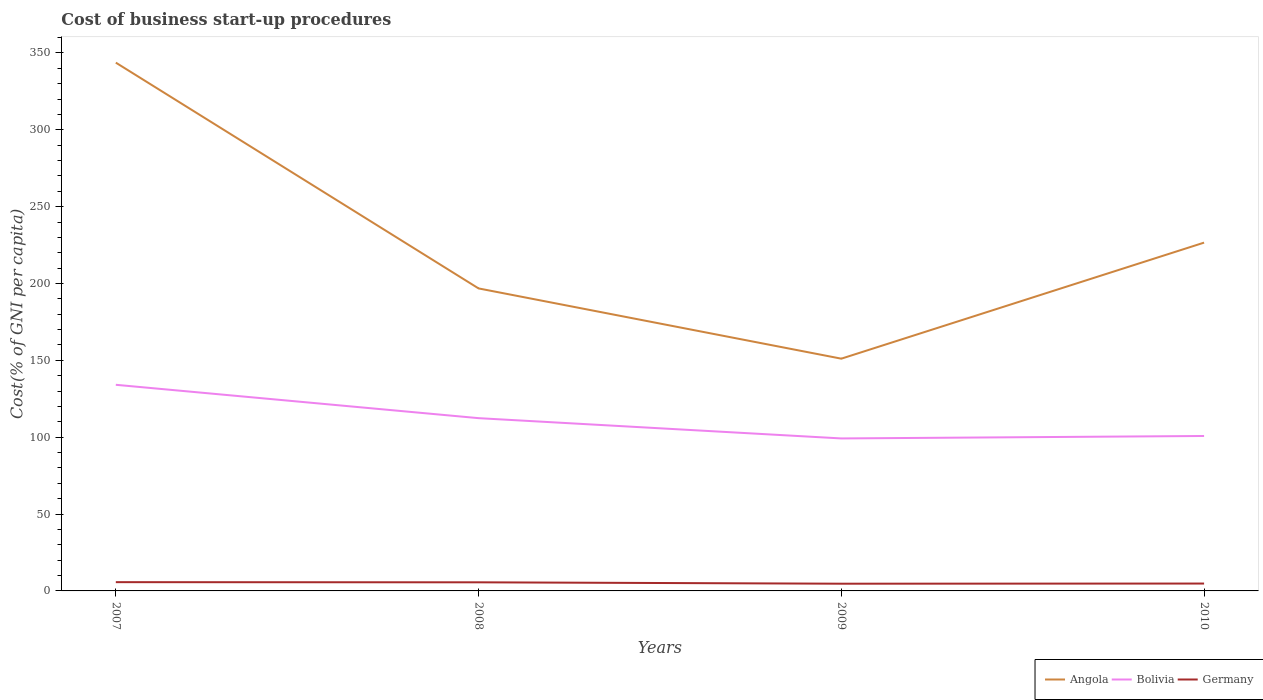Across all years, what is the maximum cost of business start-up procedures in Bolivia?
Your response must be concise. 99.2. What is the total cost of business start-up procedures in Germany in the graph?
Provide a short and direct response. 0.9. What is the difference between the highest and the second highest cost of business start-up procedures in Angola?
Ensure brevity in your answer.  192.6. What is the difference between the highest and the lowest cost of business start-up procedures in Germany?
Your response must be concise. 2. Is the cost of business start-up procedures in Bolivia strictly greater than the cost of business start-up procedures in Germany over the years?
Keep it short and to the point. No. How many lines are there?
Provide a short and direct response. 3. How many years are there in the graph?
Offer a terse response. 4. What is the difference between two consecutive major ticks on the Y-axis?
Provide a short and direct response. 50. What is the title of the graph?
Your response must be concise. Cost of business start-up procedures. Does "OECD members" appear as one of the legend labels in the graph?
Give a very brief answer. No. What is the label or title of the X-axis?
Your answer should be very brief. Years. What is the label or title of the Y-axis?
Make the answer very short. Cost(% of GNI per capita). What is the Cost(% of GNI per capita) of Angola in 2007?
Make the answer very short. 343.7. What is the Cost(% of GNI per capita) in Bolivia in 2007?
Offer a very short reply. 134.1. What is the Cost(% of GNI per capita) of Angola in 2008?
Give a very brief answer. 196.8. What is the Cost(% of GNI per capita) of Bolivia in 2008?
Make the answer very short. 112.4. What is the Cost(% of GNI per capita) in Angola in 2009?
Give a very brief answer. 151.1. What is the Cost(% of GNI per capita) of Bolivia in 2009?
Provide a succinct answer. 99.2. What is the Cost(% of GNI per capita) in Angola in 2010?
Your response must be concise. 226.6. What is the Cost(% of GNI per capita) of Bolivia in 2010?
Make the answer very short. 100.8. What is the Cost(% of GNI per capita) of Germany in 2010?
Keep it short and to the point. 4.8. Across all years, what is the maximum Cost(% of GNI per capita) of Angola?
Your response must be concise. 343.7. Across all years, what is the maximum Cost(% of GNI per capita) of Bolivia?
Make the answer very short. 134.1. Across all years, what is the maximum Cost(% of GNI per capita) in Germany?
Provide a short and direct response. 5.7. Across all years, what is the minimum Cost(% of GNI per capita) in Angola?
Provide a short and direct response. 151.1. Across all years, what is the minimum Cost(% of GNI per capita) in Bolivia?
Offer a very short reply. 99.2. Across all years, what is the minimum Cost(% of GNI per capita) of Germany?
Offer a very short reply. 4.7. What is the total Cost(% of GNI per capita) of Angola in the graph?
Your response must be concise. 918.2. What is the total Cost(% of GNI per capita) of Bolivia in the graph?
Keep it short and to the point. 446.5. What is the total Cost(% of GNI per capita) in Germany in the graph?
Provide a short and direct response. 20.8. What is the difference between the Cost(% of GNI per capita) of Angola in 2007 and that in 2008?
Keep it short and to the point. 146.9. What is the difference between the Cost(% of GNI per capita) in Bolivia in 2007 and that in 2008?
Your answer should be compact. 21.7. What is the difference between the Cost(% of GNI per capita) in Germany in 2007 and that in 2008?
Offer a terse response. 0.1. What is the difference between the Cost(% of GNI per capita) of Angola in 2007 and that in 2009?
Your answer should be compact. 192.6. What is the difference between the Cost(% of GNI per capita) in Bolivia in 2007 and that in 2009?
Offer a very short reply. 34.9. What is the difference between the Cost(% of GNI per capita) in Germany in 2007 and that in 2009?
Offer a terse response. 1. What is the difference between the Cost(% of GNI per capita) in Angola in 2007 and that in 2010?
Provide a short and direct response. 117.1. What is the difference between the Cost(% of GNI per capita) of Bolivia in 2007 and that in 2010?
Ensure brevity in your answer.  33.3. What is the difference between the Cost(% of GNI per capita) in Angola in 2008 and that in 2009?
Offer a very short reply. 45.7. What is the difference between the Cost(% of GNI per capita) of Bolivia in 2008 and that in 2009?
Ensure brevity in your answer.  13.2. What is the difference between the Cost(% of GNI per capita) of Germany in 2008 and that in 2009?
Make the answer very short. 0.9. What is the difference between the Cost(% of GNI per capita) of Angola in 2008 and that in 2010?
Provide a short and direct response. -29.8. What is the difference between the Cost(% of GNI per capita) in Angola in 2009 and that in 2010?
Ensure brevity in your answer.  -75.5. What is the difference between the Cost(% of GNI per capita) in Bolivia in 2009 and that in 2010?
Offer a very short reply. -1.6. What is the difference between the Cost(% of GNI per capita) of Angola in 2007 and the Cost(% of GNI per capita) of Bolivia in 2008?
Your answer should be very brief. 231.3. What is the difference between the Cost(% of GNI per capita) of Angola in 2007 and the Cost(% of GNI per capita) of Germany in 2008?
Give a very brief answer. 338.1. What is the difference between the Cost(% of GNI per capita) of Bolivia in 2007 and the Cost(% of GNI per capita) of Germany in 2008?
Offer a terse response. 128.5. What is the difference between the Cost(% of GNI per capita) of Angola in 2007 and the Cost(% of GNI per capita) of Bolivia in 2009?
Offer a very short reply. 244.5. What is the difference between the Cost(% of GNI per capita) in Angola in 2007 and the Cost(% of GNI per capita) in Germany in 2009?
Your response must be concise. 339. What is the difference between the Cost(% of GNI per capita) of Bolivia in 2007 and the Cost(% of GNI per capita) of Germany in 2009?
Make the answer very short. 129.4. What is the difference between the Cost(% of GNI per capita) of Angola in 2007 and the Cost(% of GNI per capita) of Bolivia in 2010?
Make the answer very short. 242.9. What is the difference between the Cost(% of GNI per capita) of Angola in 2007 and the Cost(% of GNI per capita) of Germany in 2010?
Make the answer very short. 338.9. What is the difference between the Cost(% of GNI per capita) in Bolivia in 2007 and the Cost(% of GNI per capita) in Germany in 2010?
Keep it short and to the point. 129.3. What is the difference between the Cost(% of GNI per capita) of Angola in 2008 and the Cost(% of GNI per capita) of Bolivia in 2009?
Provide a succinct answer. 97.6. What is the difference between the Cost(% of GNI per capita) of Angola in 2008 and the Cost(% of GNI per capita) of Germany in 2009?
Ensure brevity in your answer.  192.1. What is the difference between the Cost(% of GNI per capita) of Bolivia in 2008 and the Cost(% of GNI per capita) of Germany in 2009?
Provide a short and direct response. 107.7. What is the difference between the Cost(% of GNI per capita) in Angola in 2008 and the Cost(% of GNI per capita) in Bolivia in 2010?
Keep it short and to the point. 96. What is the difference between the Cost(% of GNI per capita) of Angola in 2008 and the Cost(% of GNI per capita) of Germany in 2010?
Provide a short and direct response. 192. What is the difference between the Cost(% of GNI per capita) in Bolivia in 2008 and the Cost(% of GNI per capita) in Germany in 2010?
Give a very brief answer. 107.6. What is the difference between the Cost(% of GNI per capita) of Angola in 2009 and the Cost(% of GNI per capita) of Bolivia in 2010?
Give a very brief answer. 50.3. What is the difference between the Cost(% of GNI per capita) of Angola in 2009 and the Cost(% of GNI per capita) of Germany in 2010?
Offer a terse response. 146.3. What is the difference between the Cost(% of GNI per capita) of Bolivia in 2009 and the Cost(% of GNI per capita) of Germany in 2010?
Offer a very short reply. 94.4. What is the average Cost(% of GNI per capita) in Angola per year?
Ensure brevity in your answer.  229.55. What is the average Cost(% of GNI per capita) of Bolivia per year?
Make the answer very short. 111.62. What is the average Cost(% of GNI per capita) of Germany per year?
Your response must be concise. 5.2. In the year 2007, what is the difference between the Cost(% of GNI per capita) of Angola and Cost(% of GNI per capita) of Bolivia?
Offer a very short reply. 209.6. In the year 2007, what is the difference between the Cost(% of GNI per capita) in Angola and Cost(% of GNI per capita) in Germany?
Your response must be concise. 338. In the year 2007, what is the difference between the Cost(% of GNI per capita) of Bolivia and Cost(% of GNI per capita) of Germany?
Your response must be concise. 128.4. In the year 2008, what is the difference between the Cost(% of GNI per capita) of Angola and Cost(% of GNI per capita) of Bolivia?
Your answer should be very brief. 84.4. In the year 2008, what is the difference between the Cost(% of GNI per capita) in Angola and Cost(% of GNI per capita) in Germany?
Offer a very short reply. 191.2. In the year 2008, what is the difference between the Cost(% of GNI per capita) in Bolivia and Cost(% of GNI per capita) in Germany?
Your answer should be compact. 106.8. In the year 2009, what is the difference between the Cost(% of GNI per capita) in Angola and Cost(% of GNI per capita) in Bolivia?
Provide a short and direct response. 51.9. In the year 2009, what is the difference between the Cost(% of GNI per capita) in Angola and Cost(% of GNI per capita) in Germany?
Provide a succinct answer. 146.4. In the year 2009, what is the difference between the Cost(% of GNI per capita) in Bolivia and Cost(% of GNI per capita) in Germany?
Your response must be concise. 94.5. In the year 2010, what is the difference between the Cost(% of GNI per capita) in Angola and Cost(% of GNI per capita) in Bolivia?
Offer a very short reply. 125.8. In the year 2010, what is the difference between the Cost(% of GNI per capita) of Angola and Cost(% of GNI per capita) of Germany?
Ensure brevity in your answer.  221.8. In the year 2010, what is the difference between the Cost(% of GNI per capita) of Bolivia and Cost(% of GNI per capita) of Germany?
Provide a short and direct response. 96. What is the ratio of the Cost(% of GNI per capita) of Angola in 2007 to that in 2008?
Provide a succinct answer. 1.75. What is the ratio of the Cost(% of GNI per capita) in Bolivia in 2007 to that in 2008?
Provide a short and direct response. 1.19. What is the ratio of the Cost(% of GNI per capita) in Germany in 2007 to that in 2008?
Keep it short and to the point. 1.02. What is the ratio of the Cost(% of GNI per capita) in Angola in 2007 to that in 2009?
Your response must be concise. 2.27. What is the ratio of the Cost(% of GNI per capita) of Bolivia in 2007 to that in 2009?
Provide a short and direct response. 1.35. What is the ratio of the Cost(% of GNI per capita) in Germany in 2007 to that in 2009?
Provide a succinct answer. 1.21. What is the ratio of the Cost(% of GNI per capita) in Angola in 2007 to that in 2010?
Provide a short and direct response. 1.52. What is the ratio of the Cost(% of GNI per capita) of Bolivia in 2007 to that in 2010?
Make the answer very short. 1.33. What is the ratio of the Cost(% of GNI per capita) of Germany in 2007 to that in 2010?
Ensure brevity in your answer.  1.19. What is the ratio of the Cost(% of GNI per capita) of Angola in 2008 to that in 2009?
Give a very brief answer. 1.3. What is the ratio of the Cost(% of GNI per capita) in Bolivia in 2008 to that in 2009?
Provide a short and direct response. 1.13. What is the ratio of the Cost(% of GNI per capita) of Germany in 2008 to that in 2009?
Keep it short and to the point. 1.19. What is the ratio of the Cost(% of GNI per capita) in Angola in 2008 to that in 2010?
Your answer should be compact. 0.87. What is the ratio of the Cost(% of GNI per capita) of Bolivia in 2008 to that in 2010?
Your response must be concise. 1.12. What is the ratio of the Cost(% of GNI per capita) of Angola in 2009 to that in 2010?
Offer a very short reply. 0.67. What is the ratio of the Cost(% of GNI per capita) of Bolivia in 2009 to that in 2010?
Provide a succinct answer. 0.98. What is the ratio of the Cost(% of GNI per capita) in Germany in 2009 to that in 2010?
Offer a terse response. 0.98. What is the difference between the highest and the second highest Cost(% of GNI per capita) of Angola?
Your response must be concise. 117.1. What is the difference between the highest and the second highest Cost(% of GNI per capita) of Bolivia?
Provide a succinct answer. 21.7. What is the difference between the highest and the lowest Cost(% of GNI per capita) of Angola?
Your answer should be very brief. 192.6. What is the difference between the highest and the lowest Cost(% of GNI per capita) of Bolivia?
Provide a succinct answer. 34.9. What is the difference between the highest and the lowest Cost(% of GNI per capita) of Germany?
Offer a terse response. 1. 